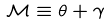Convert formula to latex. <formula><loc_0><loc_0><loc_500><loc_500>\mathcal { M } \equiv \theta + \gamma</formula> 